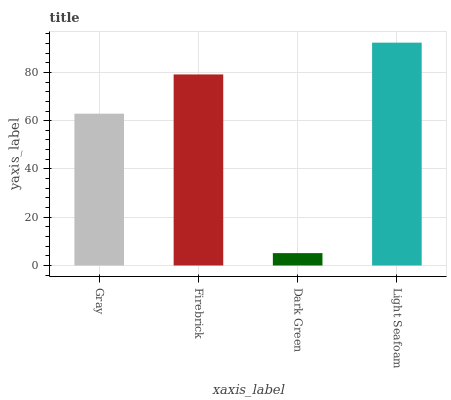Is Dark Green the minimum?
Answer yes or no. Yes. Is Light Seafoam the maximum?
Answer yes or no. Yes. Is Firebrick the minimum?
Answer yes or no. No. Is Firebrick the maximum?
Answer yes or no. No. Is Firebrick greater than Gray?
Answer yes or no. Yes. Is Gray less than Firebrick?
Answer yes or no. Yes. Is Gray greater than Firebrick?
Answer yes or no. No. Is Firebrick less than Gray?
Answer yes or no. No. Is Firebrick the high median?
Answer yes or no. Yes. Is Gray the low median?
Answer yes or no. Yes. Is Gray the high median?
Answer yes or no. No. Is Light Seafoam the low median?
Answer yes or no. No. 